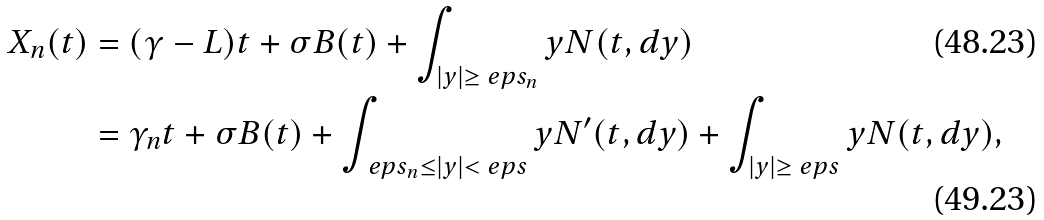Convert formula to latex. <formula><loc_0><loc_0><loc_500><loc_500>X _ { n } ( t ) & = ( \gamma - L ) t + \sigma B ( t ) + \int _ { | y | \geq \ e p s _ { n } } y N ( t , d y ) \\ & = \gamma _ { n } t + \sigma B ( t ) + \int _ { \ e p s _ { n } \leq | y | < \ e p s } y N ^ { \prime } ( t , d y ) + \int _ { | y | \geq \ e p s } y N ( t , d y ) ,</formula> 